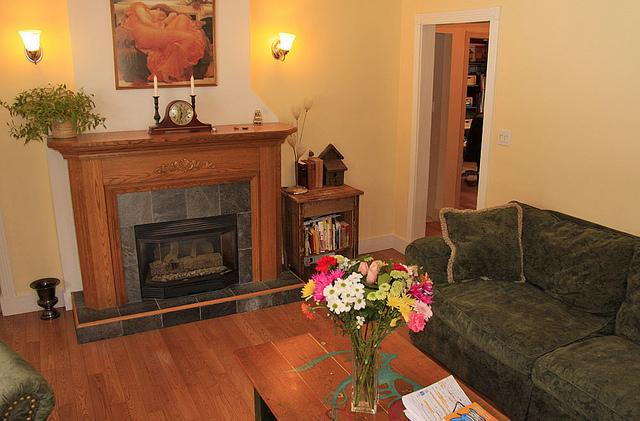How many portraits are hung above the fireplace mantle? Please explain your reasoning. one. There is a single portrait hung above the fireplace mantle. 